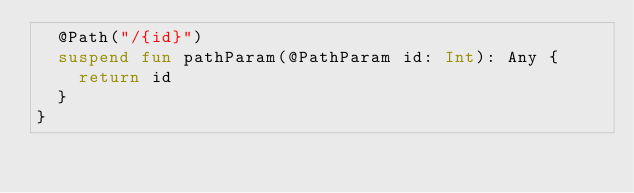<code> <loc_0><loc_0><loc_500><loc_500><_Kotlin_>  @Path("/{id}")
  suspend fun pathParam(@PathParam id: Int): Any {
    return id
  }
}
</code> 